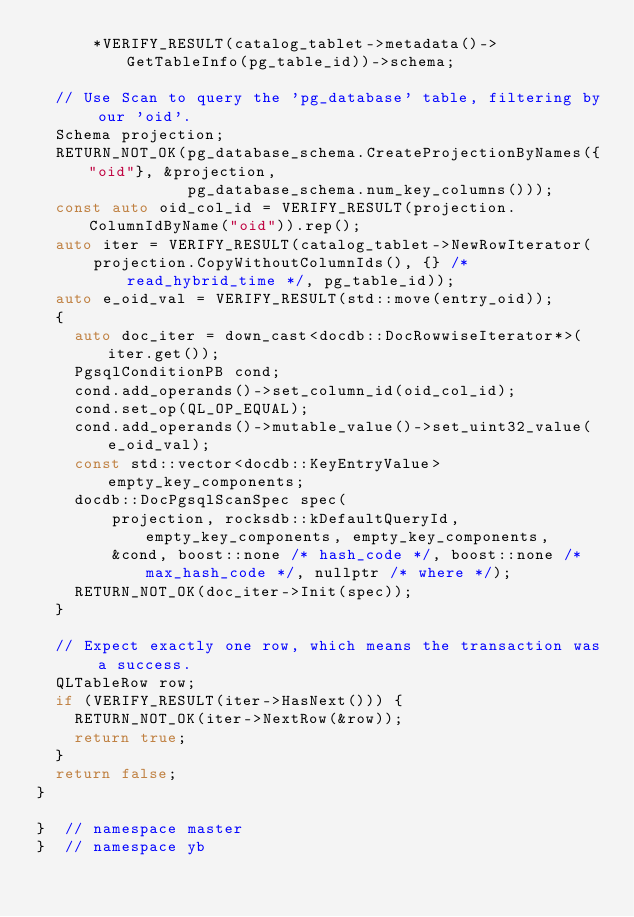Convert code to text. <code><loc_0><loc_0><loc_500><loc_500><_C++_>      *VERIFY_RESULT(catalog_tablet->metadata()->GetTableInfo(pg_table_id))->schema;

  // Use Scan to query the 'pg_database' table, filtering by our 'oid'.
  Schema projection;
  RETURN_NOT_OK(pg_database_schema.CreateProjectionByNames({"oid"}, &projection,
                pg_database_schema.num_key_columns()));
  const auto oid_col_id = VERIFY_RESULT(projection.ColumnIdByName("oid")).rep();
  auto iter = VERIFY_RESULT(catalog_tablet->NewRowIterator(
      projection.CopyWithoutColumnIds(), {} /* read_hybrid_time */, pg_table_id));
  auto e_oid_val = VERIFY_RESULT(std::move(entry_oid));
  {
    auto doc_iter = down_cast<docdb::DocRowwiseIterator*>(iter.get());
    PgsqlConditionPB cond;
    cond.add_operands()->set_column_id(oid_col_id);
    cond.set_op(QL_OP_EQUAL);
    cond.add_operands()->mutable_value()->set_uint32_value(e_oid_val);
    const std::vector<docdb::KeyEntryValue> empty_key_components;
    docdb::DocPgsqlScanSpec spec(
        projection, rocksdb::kDefaultQueryId, empty_key_components, empty_key_components,
        &cond, boost::none /* hash_code */, boost::none /* max_hash_code */, nullptr /* where */);
    RETURN_NOT_OK(doc_iter->Init(spec));
  }

  // Expect exactly one row, which means the transaction was a success.
  QLTableRow row;
  if (VERIFY_RESULT(iter->HasNext())) {
    RETURN_NOT_OK(iter->NextRow(&row));
    return true;
  }
  return false;
}

}  // namespace master
}  // namespace yb
</code> 